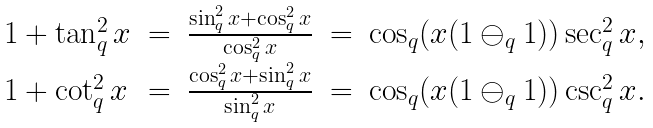<formula> <loc_0><loc_0><loc_500><loc_500>\begin{array} { l l l l l } 1 + \tan _ { q } ^ { 2 } x & = & \frac { \sin _ { q } ^ { 2 } x + \cos _ { q } ^ { 2 } x } { \cos _ { q } ^ { 2 } x } & = & \cos _ { q } ( x ( 1 \ominus _ { q } 1 ) ) \sec _ { q } ^ { 2 } x , \\ 1 + \cot _ { q } ^ { 2 } x & = & \frac { \cos _ { q } ^ { 2 } x + \sin _ { q } ^ { 2 } x } { \sin _ { q } ^ { 2 } x } & = & \cos _ { q } ( x ( 1 \ominus _ { q } 1 ) ) \csc _ { q } ^ { 2 } x . \end{array}</formula> 